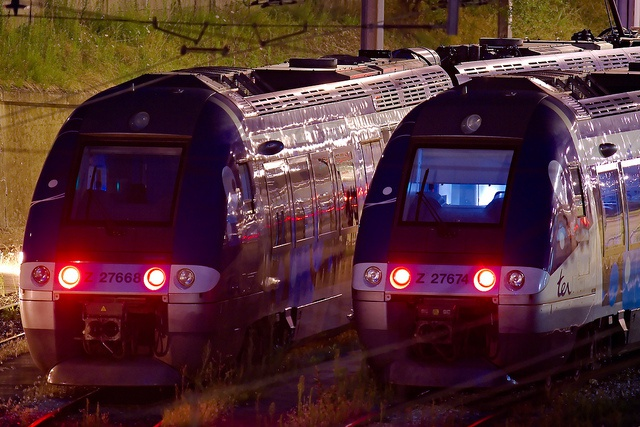Describe the objects in this image and their specific colors. I can see train in olive, black, maroon, brown, and darkgray tones and train in olive, black, maroon, purple, and darkgray tones in this image. 